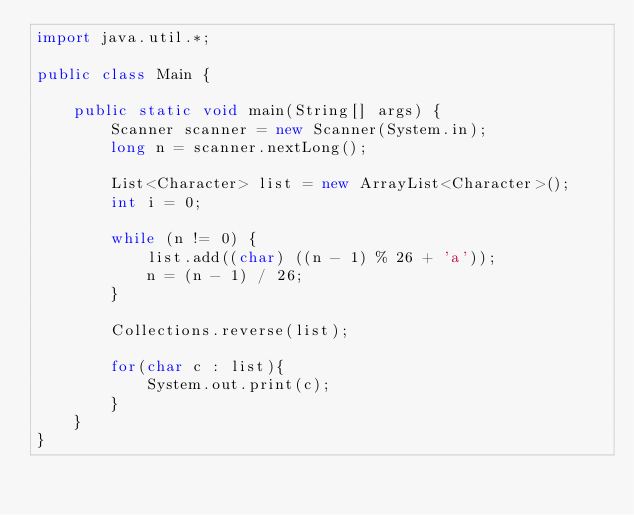Convert code to text. <code><loc_0><loc_0><loc_500><loc_500><_Java_>import java.util.*;

public class Main {

    public static void main(String[] args) {
        Scanner scanner = new Scanner(System.in);
        long n = scanner.nextLong();
        
        List<Character> list = new ArrayList<Character>();
        int i = 0;
        
        while (n != 0) {
            list.add((char) ((n - 1) % 26 + 'a'));
            n = (n - 1) / 26;
        }
        
        Collections.reverse(list);
        
        for(char c : list){
            System.out.print(c);
        }
    }
}</code> 